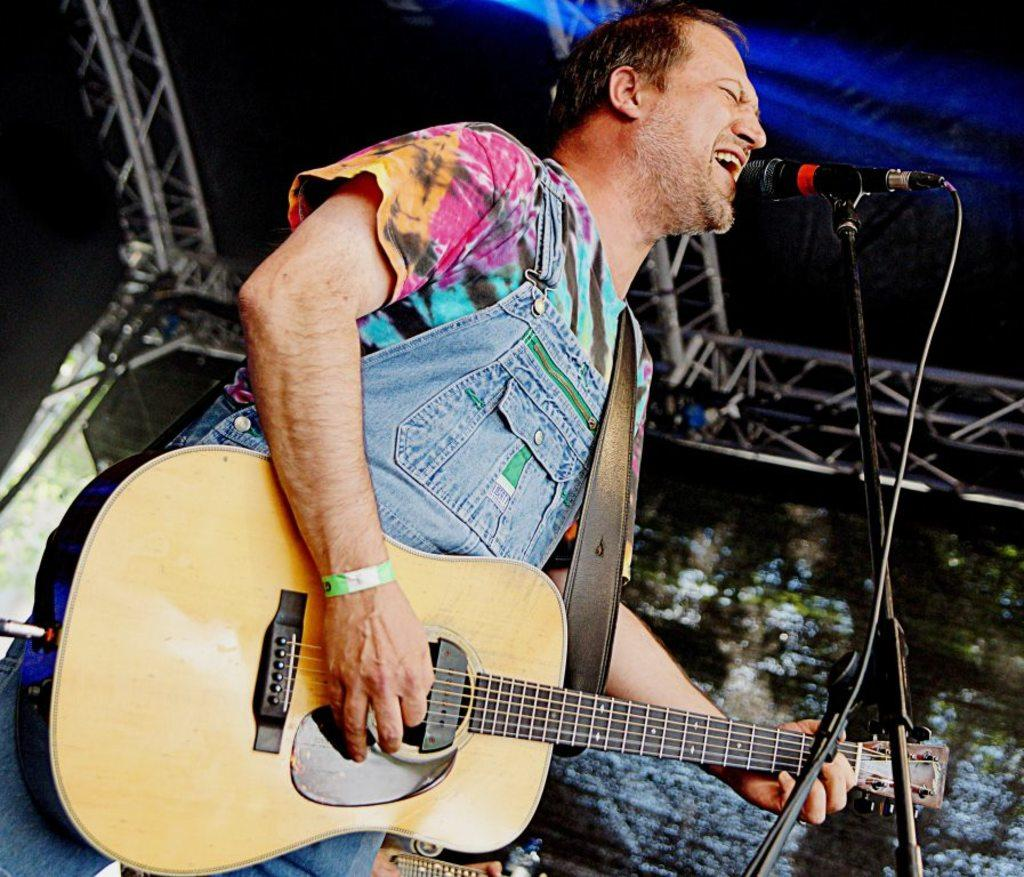Who is the main subject in the image? There is a man in the image. What is the man doing in the image? The man is playing a guitar and singing a song. What object is in front of the man? There is a microphone in front of the man. What type of steel is the man using to play the guitar in the image? The image does not provide information about the type of steel used in the guitar, nor does it show any steel being used. 